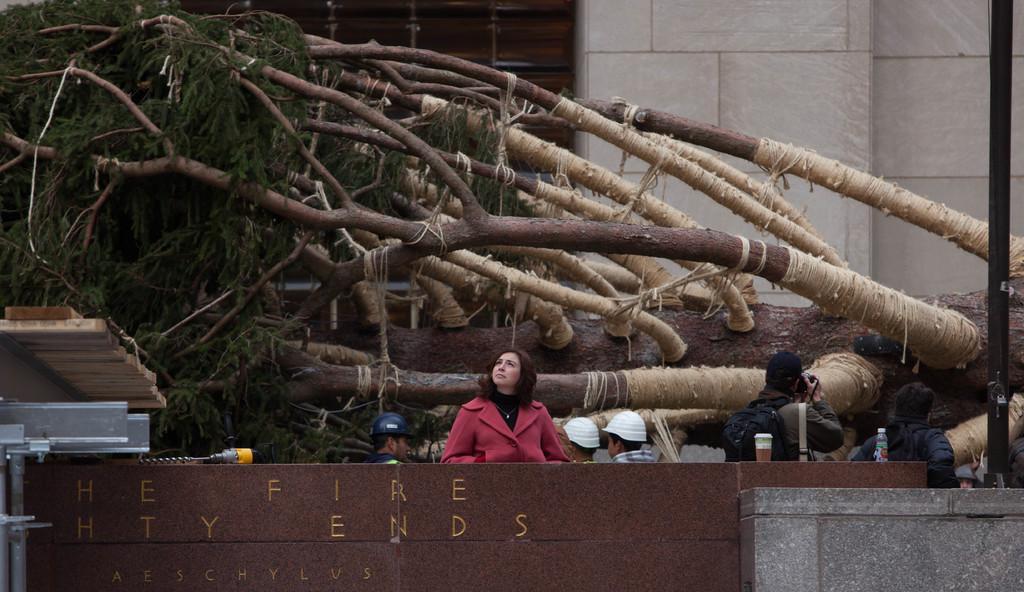Describe this image in one or two sentences. In this image, we can see people, bottle, cup, pole, wooden objects, drilling machine and tree. In the background, we can see wall. On the right side of the image, we can see a person holding a camera. At the bottom of the image, we can see wall, poles and some text on the object. 